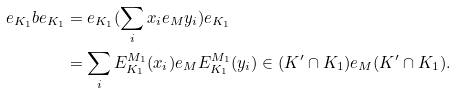<formula> <loc_0><loc_0><loc_500><loc_500>e _ { K _ { 1 } } b e _ { K _ { 1 } } & = e _ { K _ { 1 } } ( \sum _ { i } x _ { i } e _ { M } y _ { i } ) e _ { K _ { 1 } } \\ & = \sum _ { i } E ^ { M _ { 1 } } _ { K _ { 1 } } ( x _ { i } ) e _ { M } E ^ { M _ { 1 } } _ { K _ { 1 } } ( y _ { i } ) \in ( K ^ { \prime } \cap K _ { 1 } ) e _ { M } ( K ^ { \prime } \cap K _ { 1 } ) .</formula> 